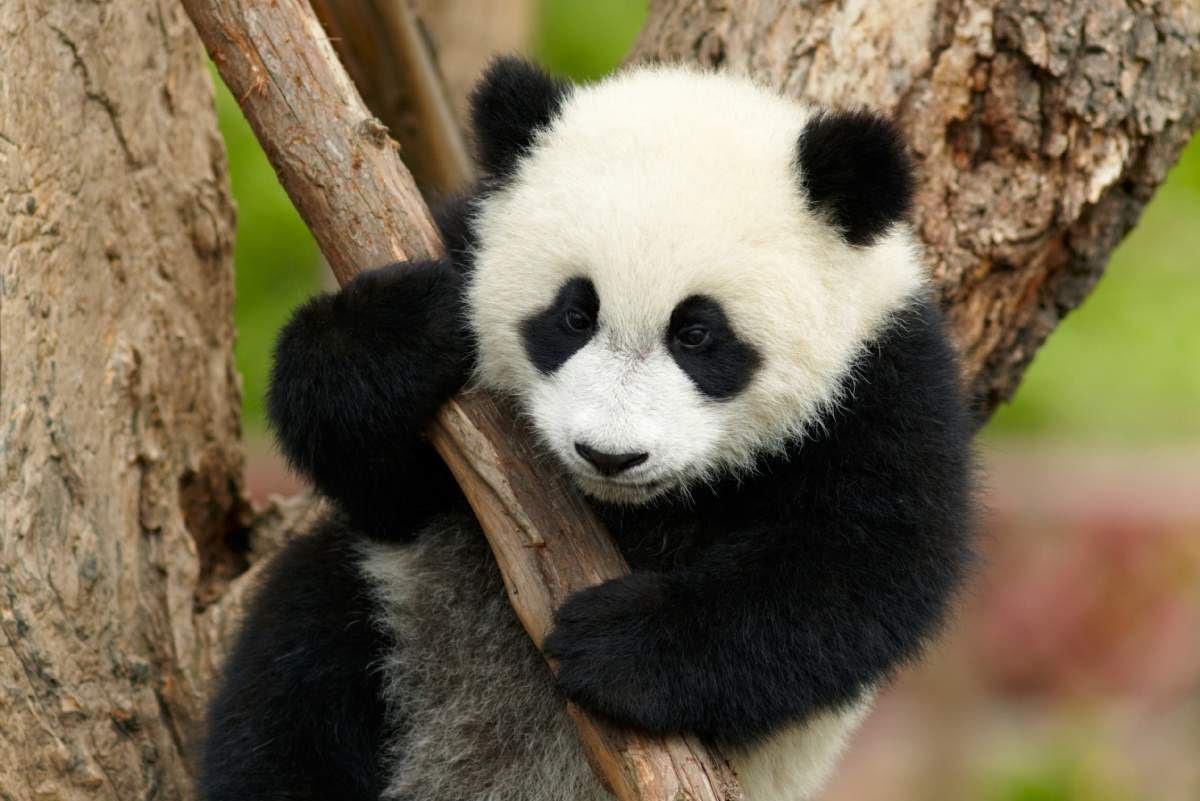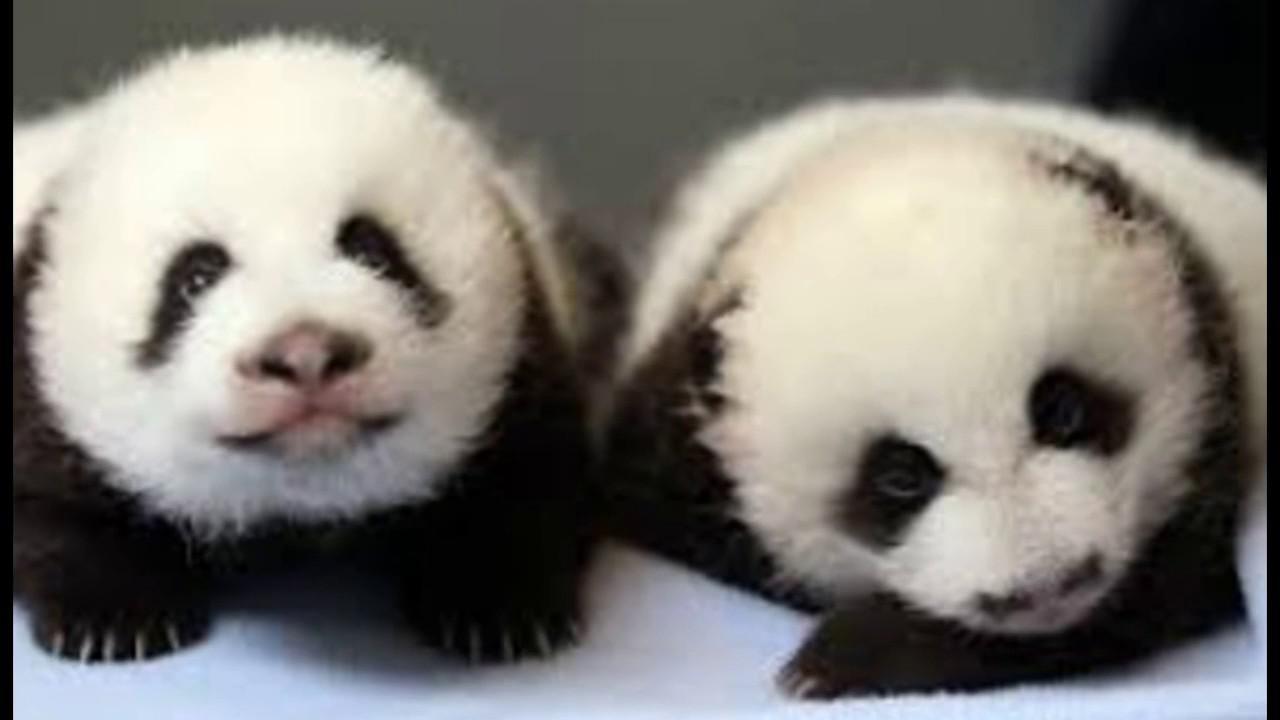The first image is the image on the left, the second image is the image on the right. For the images shown, is this caption "One panda is eating bamboo." true? Answer yes or no. No. The first image is the image on the left, the second image is the image on the right. Analyze the images presented: Is the assertion "a panda is eating bamboo" valid? Answer yes or no. No. 